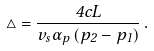<formula> <loc_0><loc_0><loc_500><loc_500>\bigtriangleup = \frac { 4 c L } { v _ { s } \alpha _ { p } \left ( p _ { 2 } - p _ { 1 } \right ) } \, .</formula> 